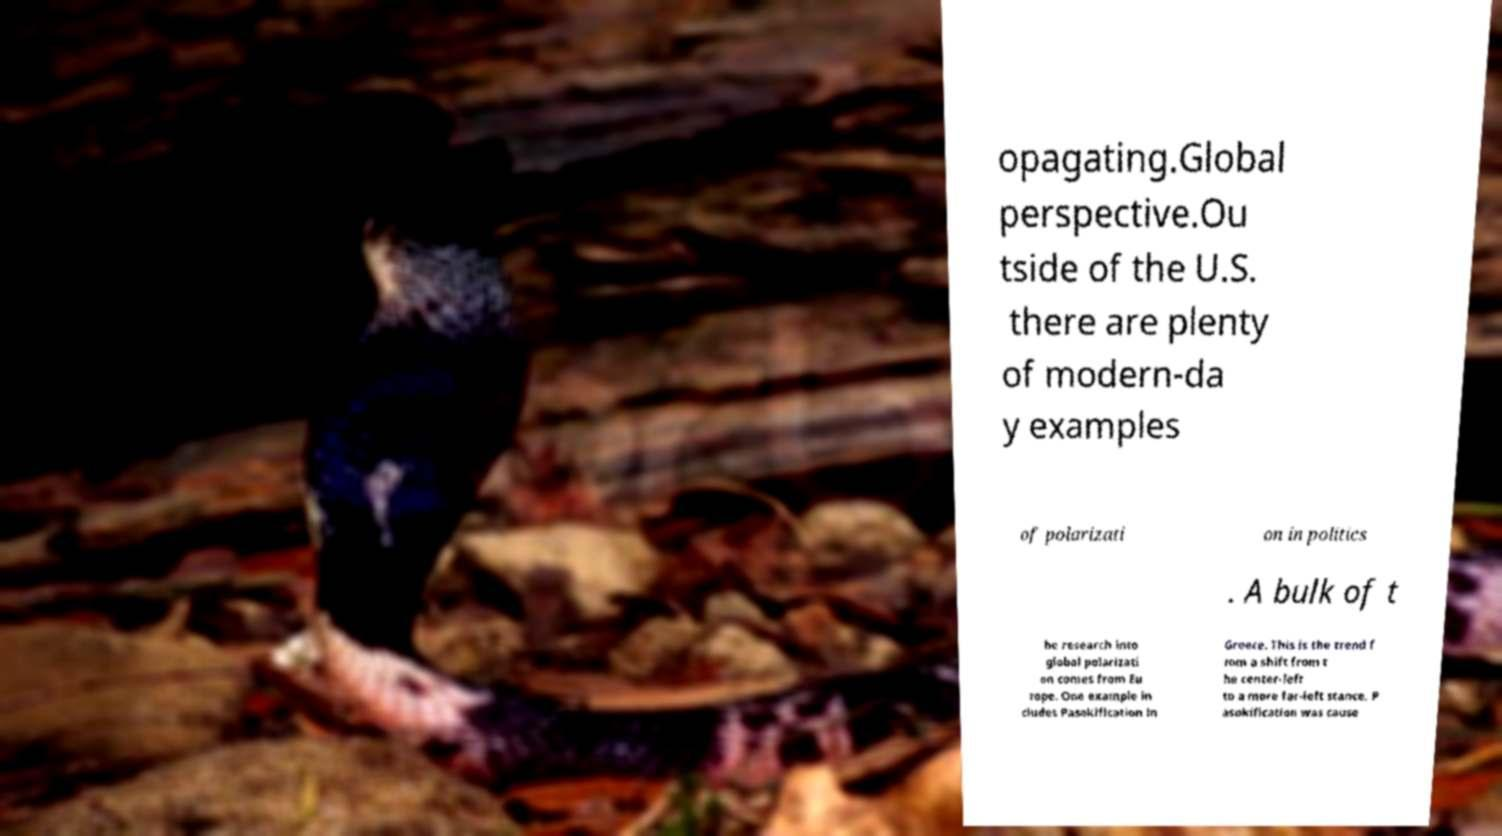Can you accurately transcribe the text from the provided image for me? opagating.Global perspective.Ou tside of the U.S. there are plenty of modern-da y examples of polarizati on in politics . A bulk of t he research into global polarizati on comes from Eu rope. One example in cludes Pasokification in Greece. This is the trend f rom a shift from t he center-left to a more far-left stance. P asokification was cause 